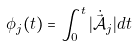<formula> <loc_0><loc_0><loc_500><loc_500>\phi _ { j } ( t ) = \int _ { 0 } ^ { t } | \dot { \vec { \mathcal { A } _ { j } } } | d t</formula> 